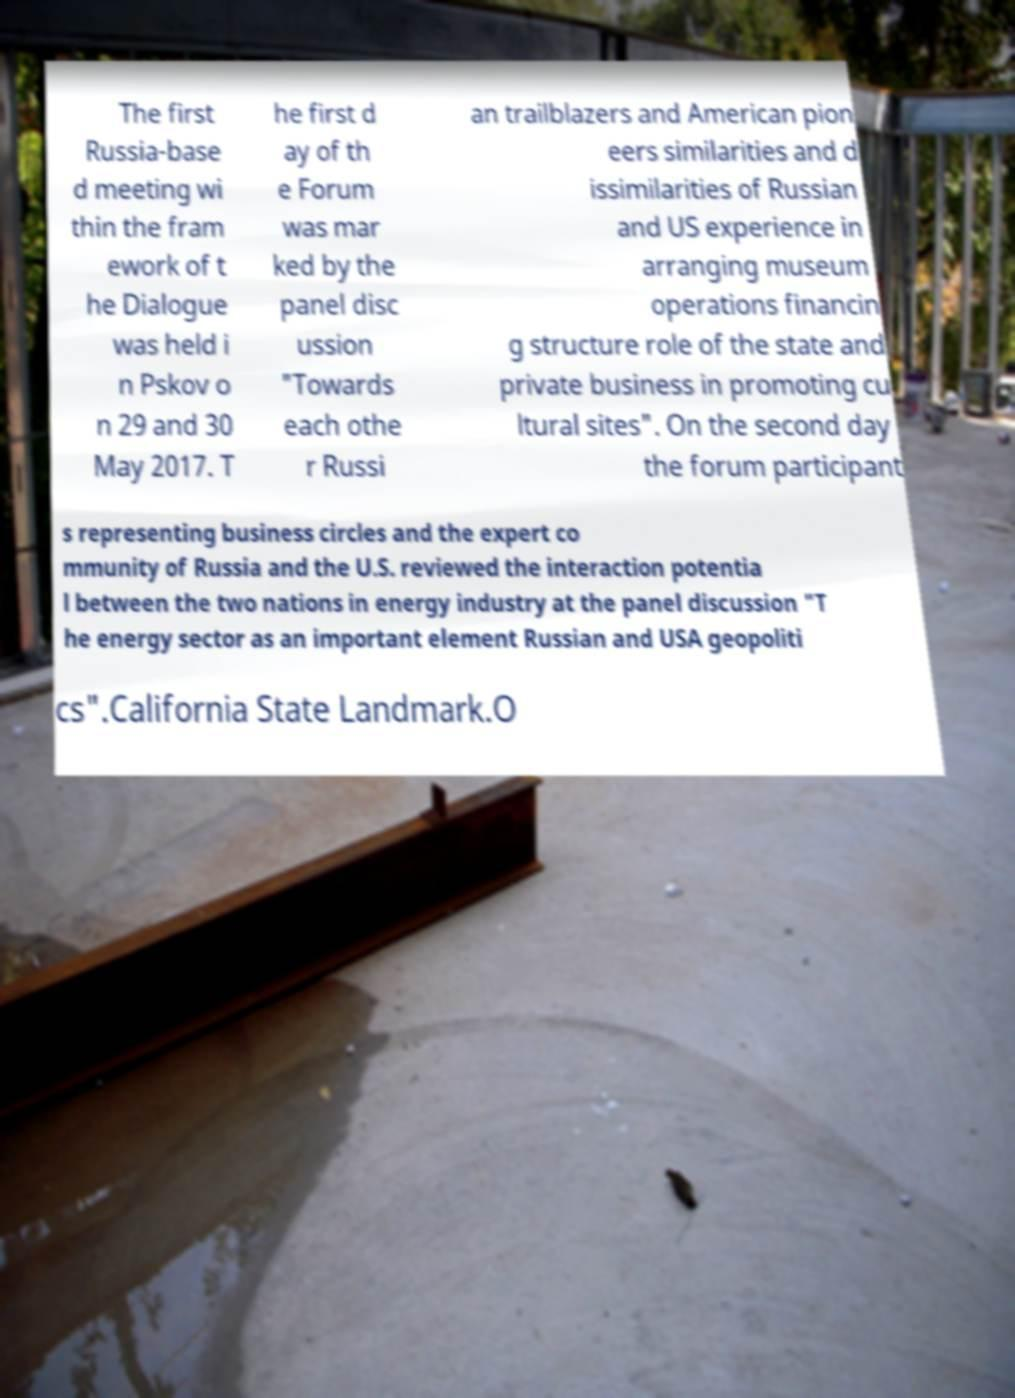Can you accurately transcribe the text from the provided image for me? The first Russia-base d meeting wi thin the fram ework of t he Dialogue was held i n Pskov o n 29 and 30 May 2017. T he first d ay of th e Forum was mar ked by the panel disc ussion "Towards each othe r Russi an trailblazers and American pion eers similarities and d issimilarities of Russian and US experience in arranging museum operations financin g structure role of the state and private business in promoting cu ltural sites". On the second day the forum participant s representing business circles and the expert co mmunity of Russia and the U.S. reviewed the interaction potentia l between the two nations in energy industry at the panel discussion "T he energy sector as an important element Russian and USA geopoliti cs".California State Landmark.O 